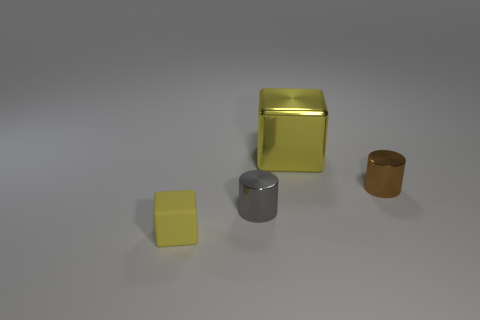There is another matte object that is the same size as the brown object; what color is it? yellow 